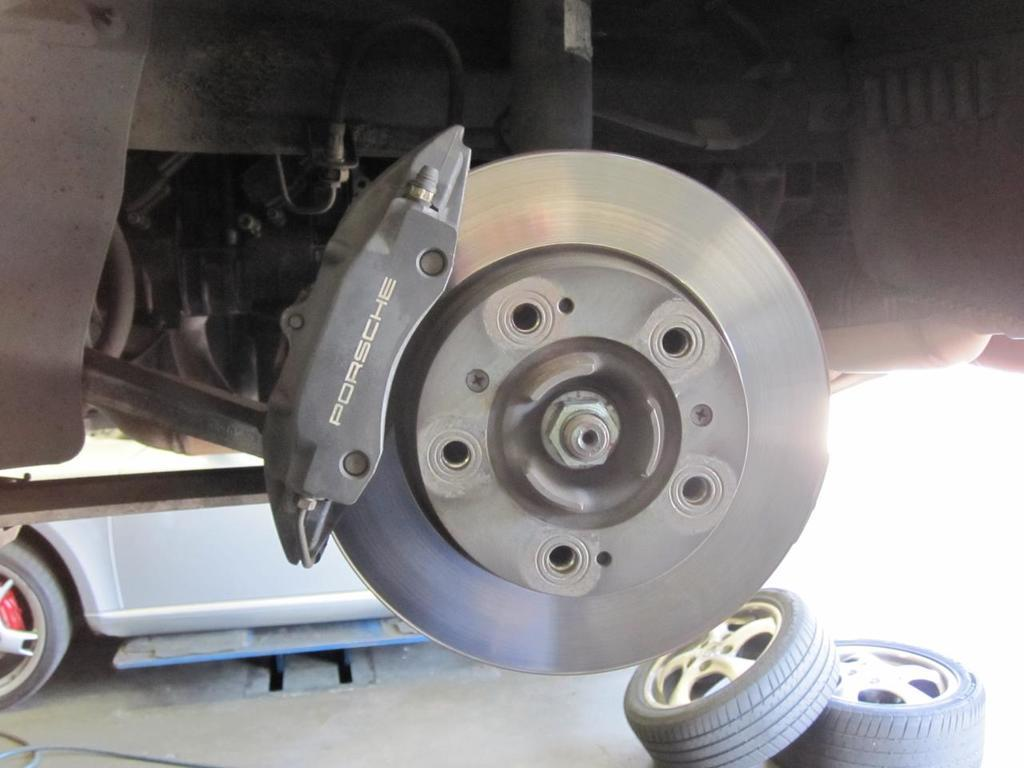What type of automotive component is featured in the image? The image contains a disc brake. What other parts of a vehicle can be seen in the image? There are tyres at the bottom of the image. Can you describe the vehicle that is visible in the image? There appears to be a vehicle on the left side of the image. What is the temperature of the blood circulating through the vehicle in the image? There is no blood present in the image, as it features a disc brake and tyres of a vehicle. 